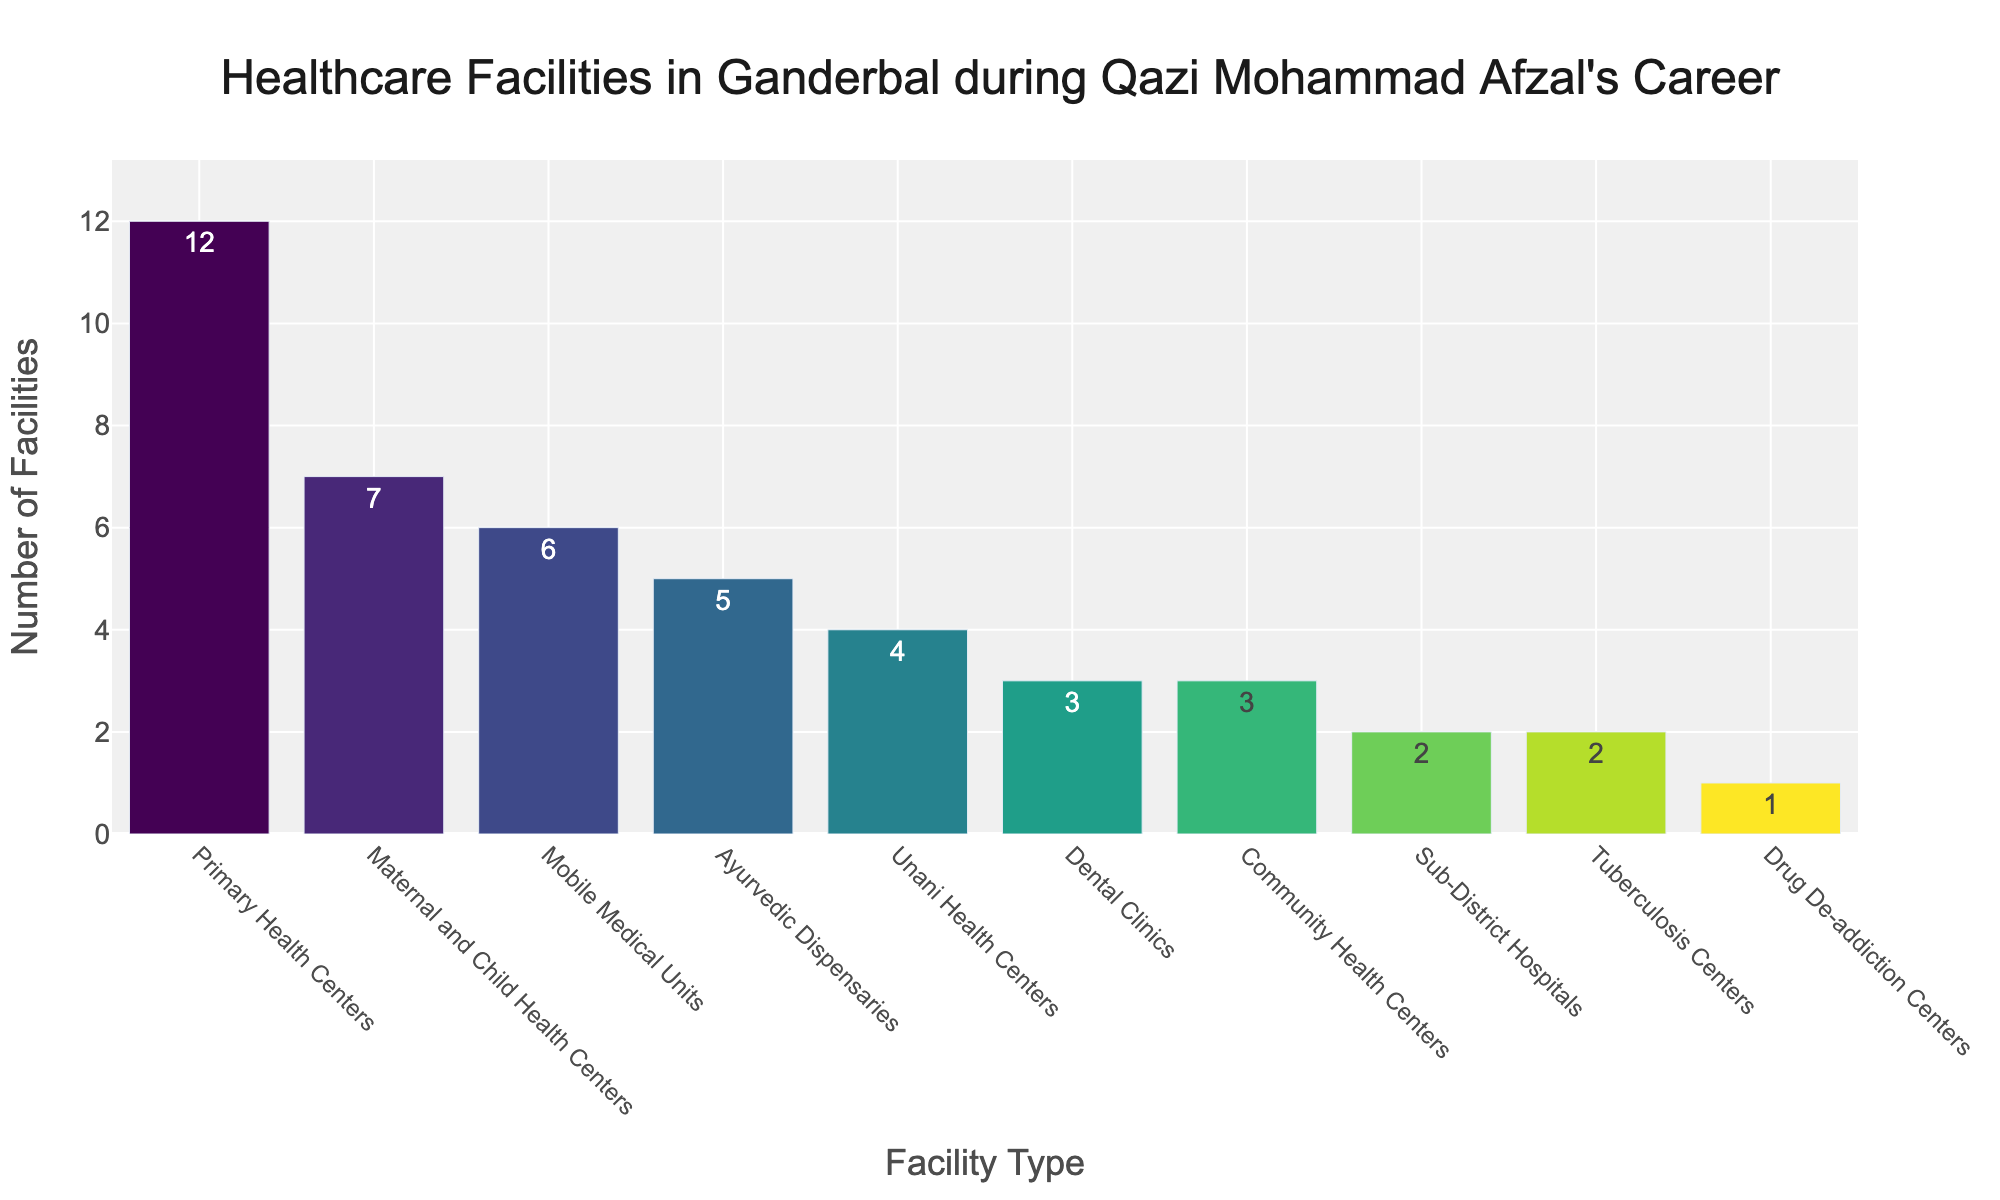What type of healthcare facility has the highest number of units? By observing the height of the bars, the bar labeled "Primary Health Centers" is the tallest, indicating it has the highest number of units.
Answer: Primary Health Centers How many more Ayurvedic Dispensaries are there compared to Unani Health Centers? The bar for Ayurvedic Dispensaries has a value of 5, and the bar for Unani Health Centers has a value of 4. The difference is calculated as 5 - 4 = 1.
Answer: 1 What is the total number of healthcare facilities excluding Primary Health Centers and Sub-District Hospitals? Summing up all the other facilities: 5 (Ayurvedic Dispensaries) + 4 (Unani Health Centers) + 3 (Dental Clinics) + 7 (Maternal and Child Health Centers) + 6 (Mobile Medical Units) + 3 (Community Health Centers) + 1 (Drug De-addiction Centers) + 2 (Tuberculosis Centers) = 31.
Answer: 31 Which facility type has equal numbers to Community Health Centers? By comparing the heights of the bars, both Community Health Centers and Dental Clinics have the same height, indicating they have equal numbers.
Answer: Dental Clinics What is the average number of facilities for the types listed? First, calculate the total number of facilities: 12 (Primary Health Centers) + 2 (Sub-District Hospitals) + 5 (Ayurvedic Dispensaries) + 4 (Unani Health Centers) + 3 (Dental Clinics) + 7 (Maternal and Child Health Centers) + 6 (Mobile Medical Units) + 3 (Community Health Centers) + 1 (Drug De-addiction Centers) + 2 (Tuberculosis Centers) = 45.  Then, divide by the number of different facility types, which is 10. The average is 45 / 10 = 4.5.
Answer: 4.5 Which three facility types have the lowest number of units? By examining the shortest bars, the facility types with the lowest numbers are Drug De-addiction Centers (1), Sub-District Hospitals (2), and Tuberculosis Centers (2).
Answer: Drug De-addiction Centers, Sub-District Hospitals, Tuberculosis Centers How many more Primary Health Centers are there than the total number of Dental Clinics and Community Health Centers combined? Primary Health Centers have 12 units. Dental Clinics have 3 units, and Community Health Centers have 3 units, making a combined total of 3 + 3 = 6. The difference is 12 - 6 = 6.
Answer: 6 